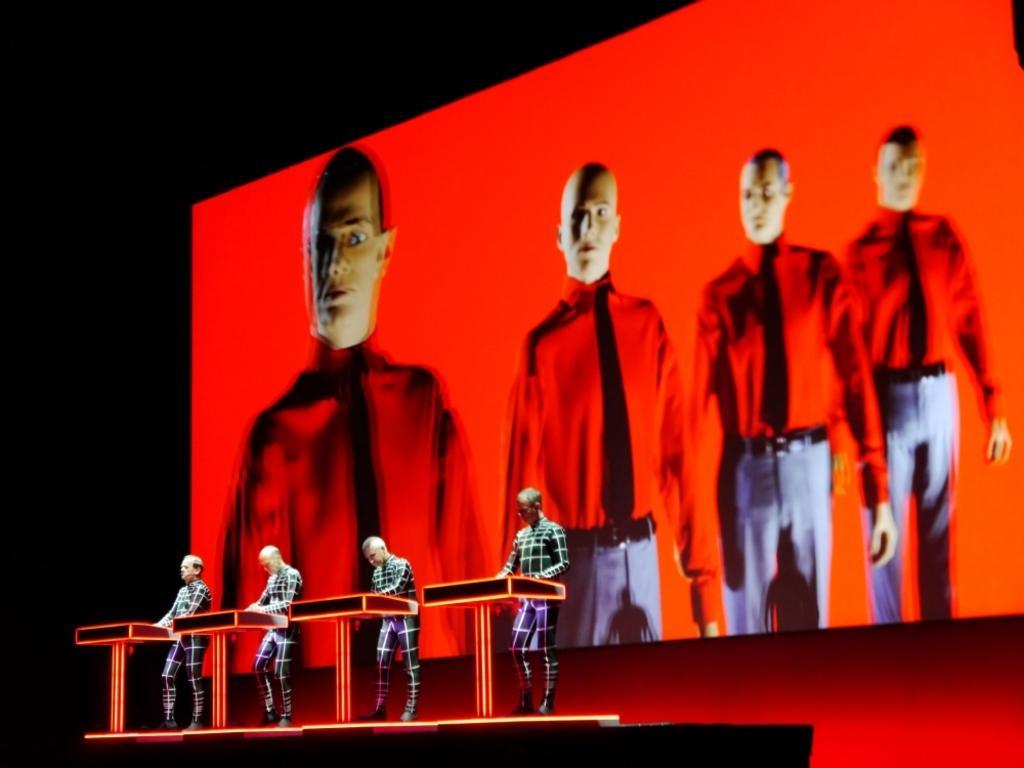Could you give a brief overview of what you see in this image? In the image there are four people standing in front of the tables and behind them there is a screen displaying four men, most of the area is filled with red light and the background is dark. 